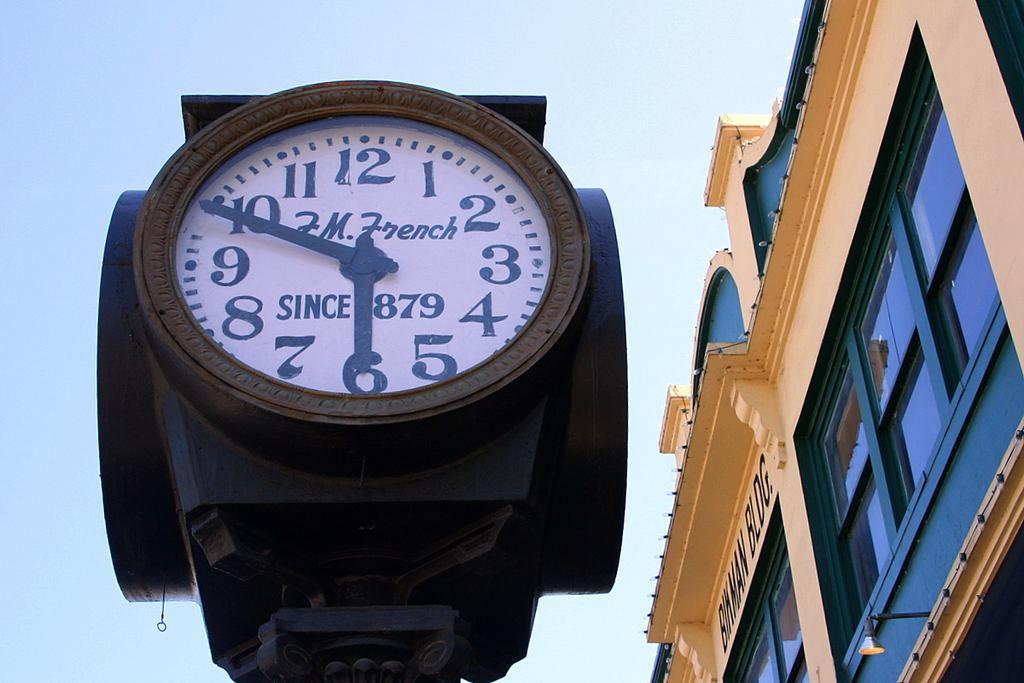Provide a one-sentence caption for the provided image. A tower clock with F.M. French on its face. 